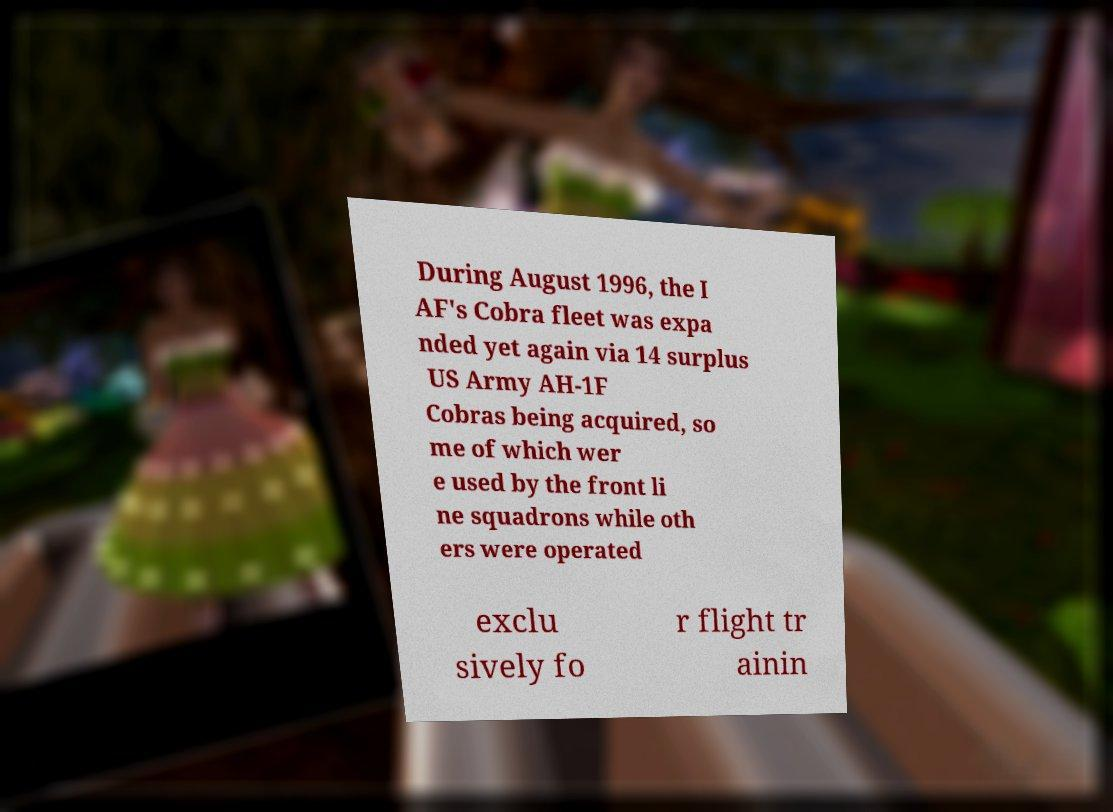Can you read and provide the text displayed in the image?This photo seems to have some interesting text. Can you extract and type it out for me? During August 1996, the I AF's Cobra fleet was expa nded yet again via 14 surplus US Army AH-1F Cobras being acquired, so me of which wer e used by the front li ne squadrons while oth ers were operated exclu sively fo r flight tr ainin 